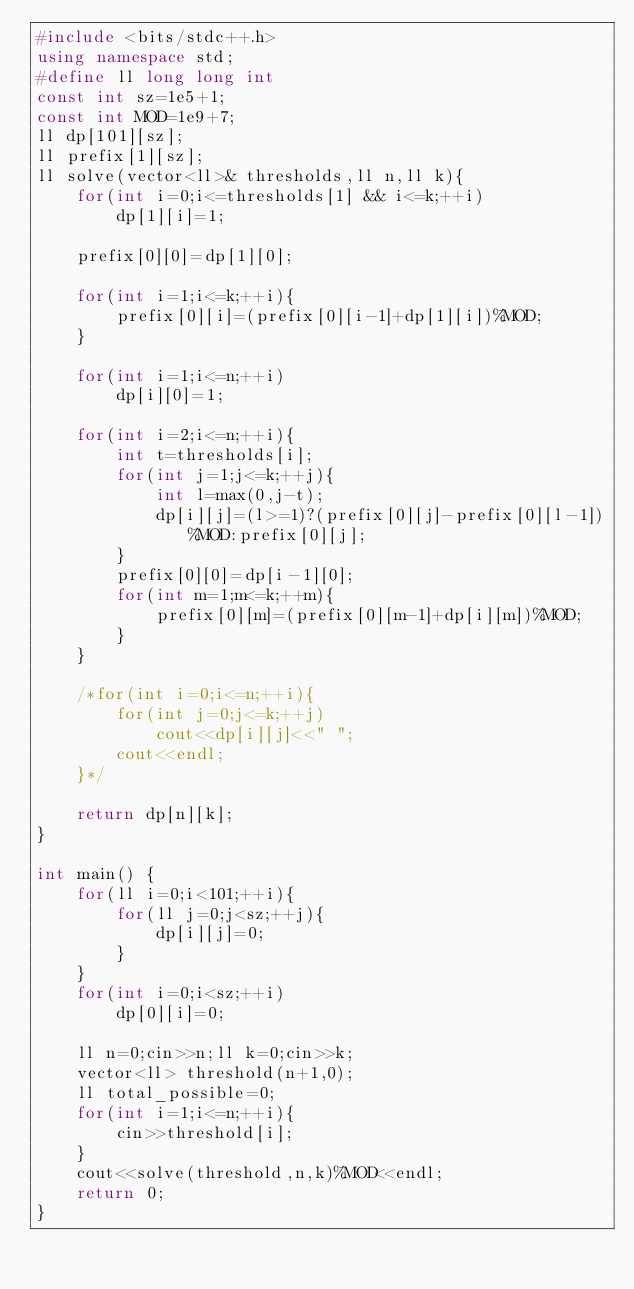Convert code to text. <code><loc_0><loc_0><loc_500><loc_500><_C++_>#include <bits/stdc++.h>
using namespace std;
#define ll long long int
const int sz=1e5+1;
const int MOD=1e9+7;
ll dp[101][sz];
ll prefix[1][sz];
ll solve(vector<ll>& thresholds,ll n,ll k){
    for(int i=0;i<=thresholds[1] && i<=k;++i)
        dp[1][i]=1;
        
    prefix[0][0]=dp[1][0];
    
    for(int i=1;i<=k;++i){
        prefix[0][i]=(prefix[0][i-1]+dp[1][i])%MOD;
    }

    for(int i=1;i<=n;++i)
        dp[i][0]=1;

    for(int i=2;i<=n;++i){
        int t=thresholds[i];
        for(int j=1;j<=k;++j){
            int l=max(0,j-t);
            dp[i][j]=(l>=1)?(prefix[0][j]-prefix[0][l-1])%MOD:prefix[0][j];
        }
        prefix[0][0]=dp[i-1][0];
        for(int m=1;m<=k;++m){
            prefix[0][m]=(prefix[0][m-1]+dp[i][m])%MOD;
        }
    }

    /*for(int i=0;i<=n;++i){
        for(int j=0;j<=k;++j)
            cout<<dp[i][j]<<" ";
        cout<<endl;
    }*/

    return dp[n][k];
}   

int main() {
    for(ll i=0;i<101;++i){
        for(ll j=0;j<sz;++j){
            dp[i][j]=0;
        }
    }
    for(int i=0;i<sz;++i)
        dp[0][i]=0;
    
    ll n=0;cin>>n;ll k=0;cin>>k;
    vector<ll> threshold(n+1,0);
    ll total_possible=0;
    for(int i=1;i<=n;++i){
        cin>>threshold[i];
    }
    cout<<solve(threshold,n,k)%MOD<<endl;
    return 0;
}
</code> 